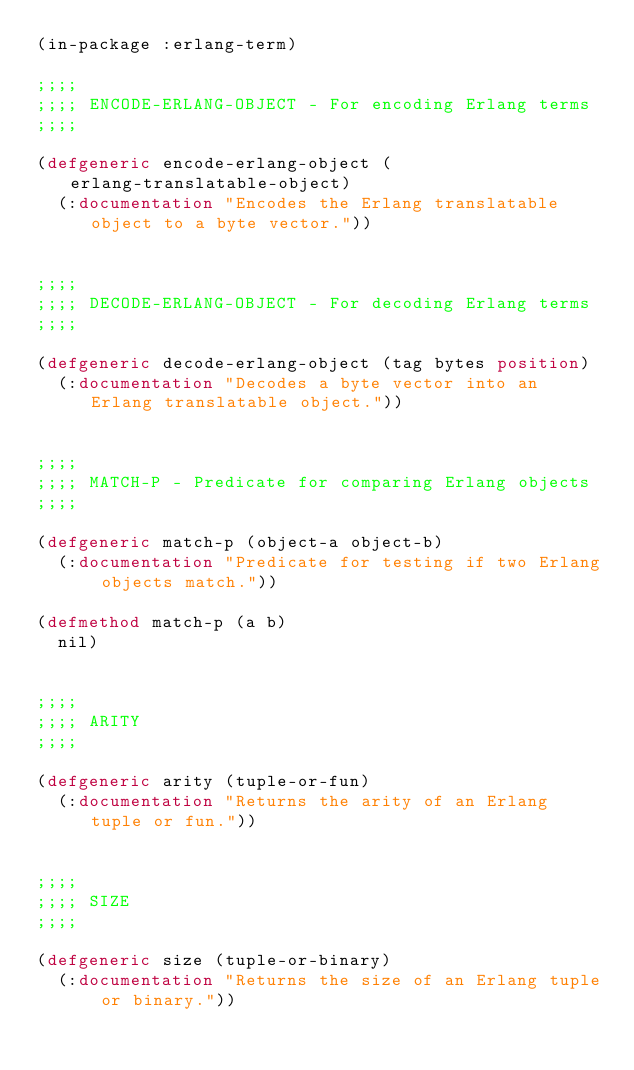Convert code to text. <code><loc_0><loc_0><loc_500><loc_500><_Lisp_>(in-package :erlang-term)

;;;;
;;;; ENCODE-ERLANG-OBJECT - For encoding Erlang terms
;;;;

(defgeneric encode-erlang-object (erlang-translatable-object)
  (:documentation "Encodes the Erlang translatable object to a byte vector."))


;;;;
;;;; DECODE-ERLANG-OBJECT - For decoding Erlang terms
;;;;

(defgeneric decode-erlang-object (tag bytes position)
  (:documentation "Decodes a byte vector into an Erlang translatable object."))


;;;;
;;;; MATCH-P - Predicate for comparing Erlang objects
;;;;

(defgeneric match-p (object-a object-b)
  (:documentation "Predicate for testing if two Erlang objects match."))

(defmethod match-p (a b)
  nil)


;;;;
;;;; ARITY
;;;;

(defgeneric arity (tuple-or-fun)
  (:documentation "Returns the arity of an Erlang tuple or fun."))


;;;;
;;;; SIZE
;;;;

(defgeneric size (tuple-or-binary)
  (:documentation "Returns the size of an Erlang tuple or binary."))
</code> 